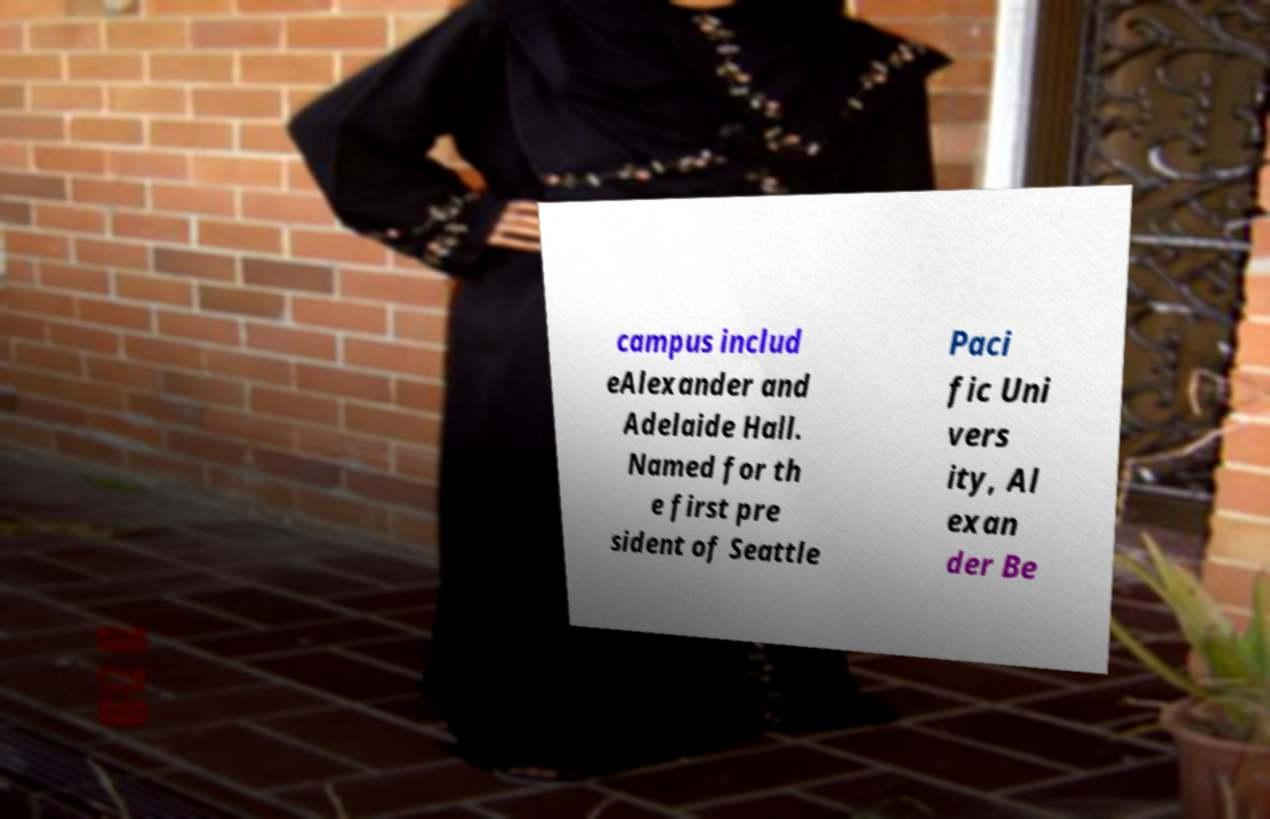Can you read and provide the text displayed in the image?This photo seems to have some interesting text. Can you extract and type it out for me? campus includ eAlexander and Adelaide Hall. Named for th e first pre sident of Seattle Paci fic Uni vers ity, Al exan der Be 